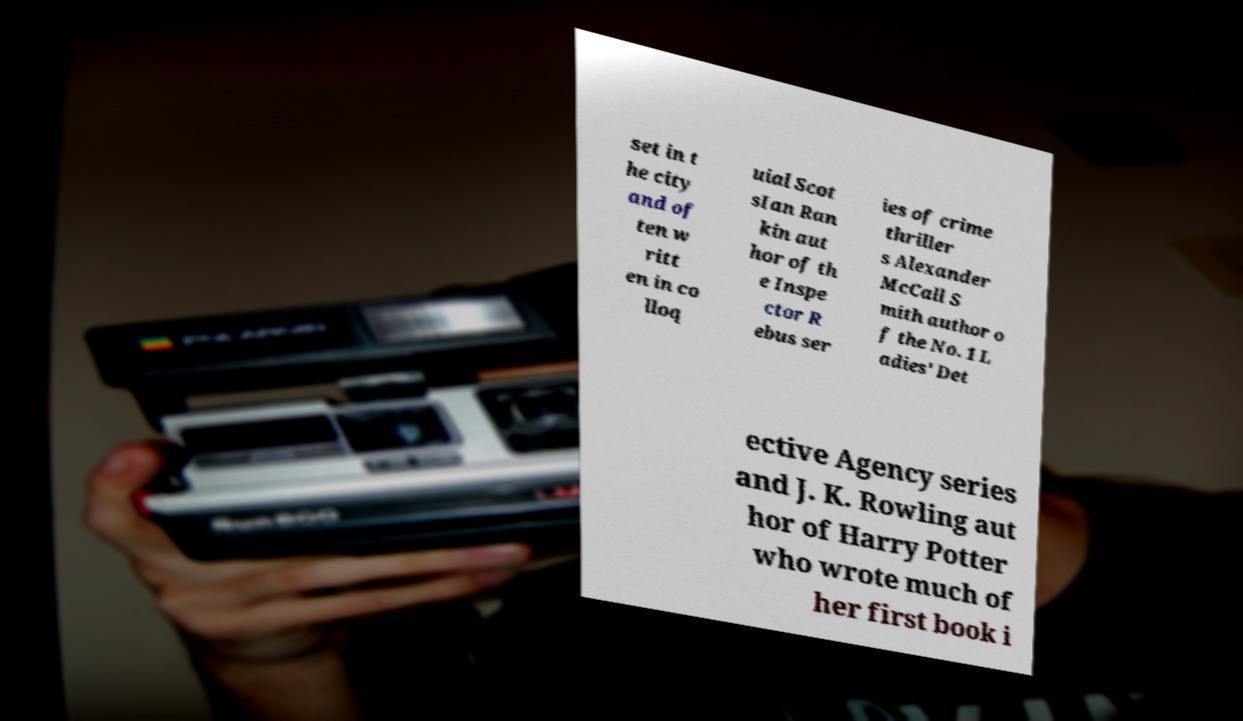Please read and relay the text visible in this image. What does it say? set in t he city and of ten w ritt en in co lloq uial Scot sIan Ran kin aut hor of th e Inspe ctor R ebus ser ies of crime thriller s Alexander McCall S mith author o f the No. 1 L adies' Det ective Agency series and J. K. Rowling aut hor of Harry Potter who wrote much of her first book i 